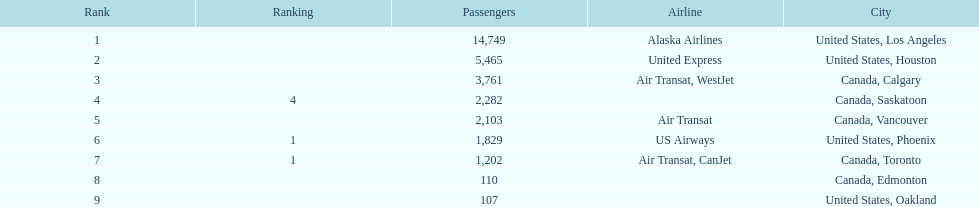Could you parse the entire table? {'header': ['Rank', 'Ranking', 'Passengers', 'Airline', 'City'], 'rows': [['1', '', '14,749', 'Alaska Airlines', 'United States, Los Angeles'], ['2', '', '5,465', 'United Express', 'United States, Houston'], ['3', '', '3,761', 'Air Transat, WestJet', 'Canada, Calgary'], ['4', '4', '2,282', '', 'Canada, Saskatoon'], ['5', '', '2,103', 'Air Transat', 'Canada, Vancouver'], ['6', '1', '1,829', 'US Airways', 'United States, Phoenix'], ['7', '1', '1,202', 'Air Transat, CanJet', 'Canada, Toronto'], ['8', '', '110', '', 'Canada, Edmonton'], ['9', '', '107', '', 'United States, Oakland']]} What was the quantity of passengers in phoenix, arizona? 1,829. 